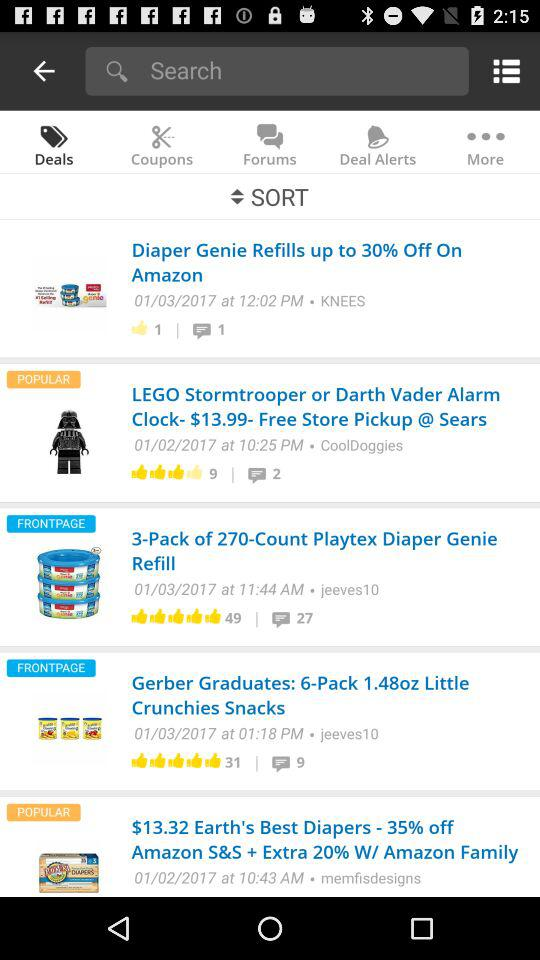How many comments are on "Crunchies Snacks"? There are 9 comments. 